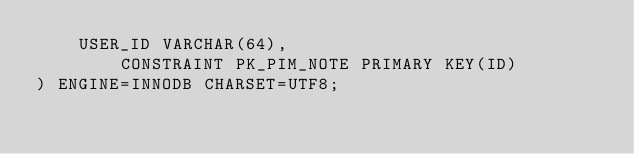<code> <loc_0><loc_0><loc_500><loc_500><_SQL_>	USER_ID VARCHAR(64),
        CONSTRAINT PK_PIM_NOTE PRIMARY KEY(ID)
) ENGINE=INNODB CHARSET=UTF8;

</code> 